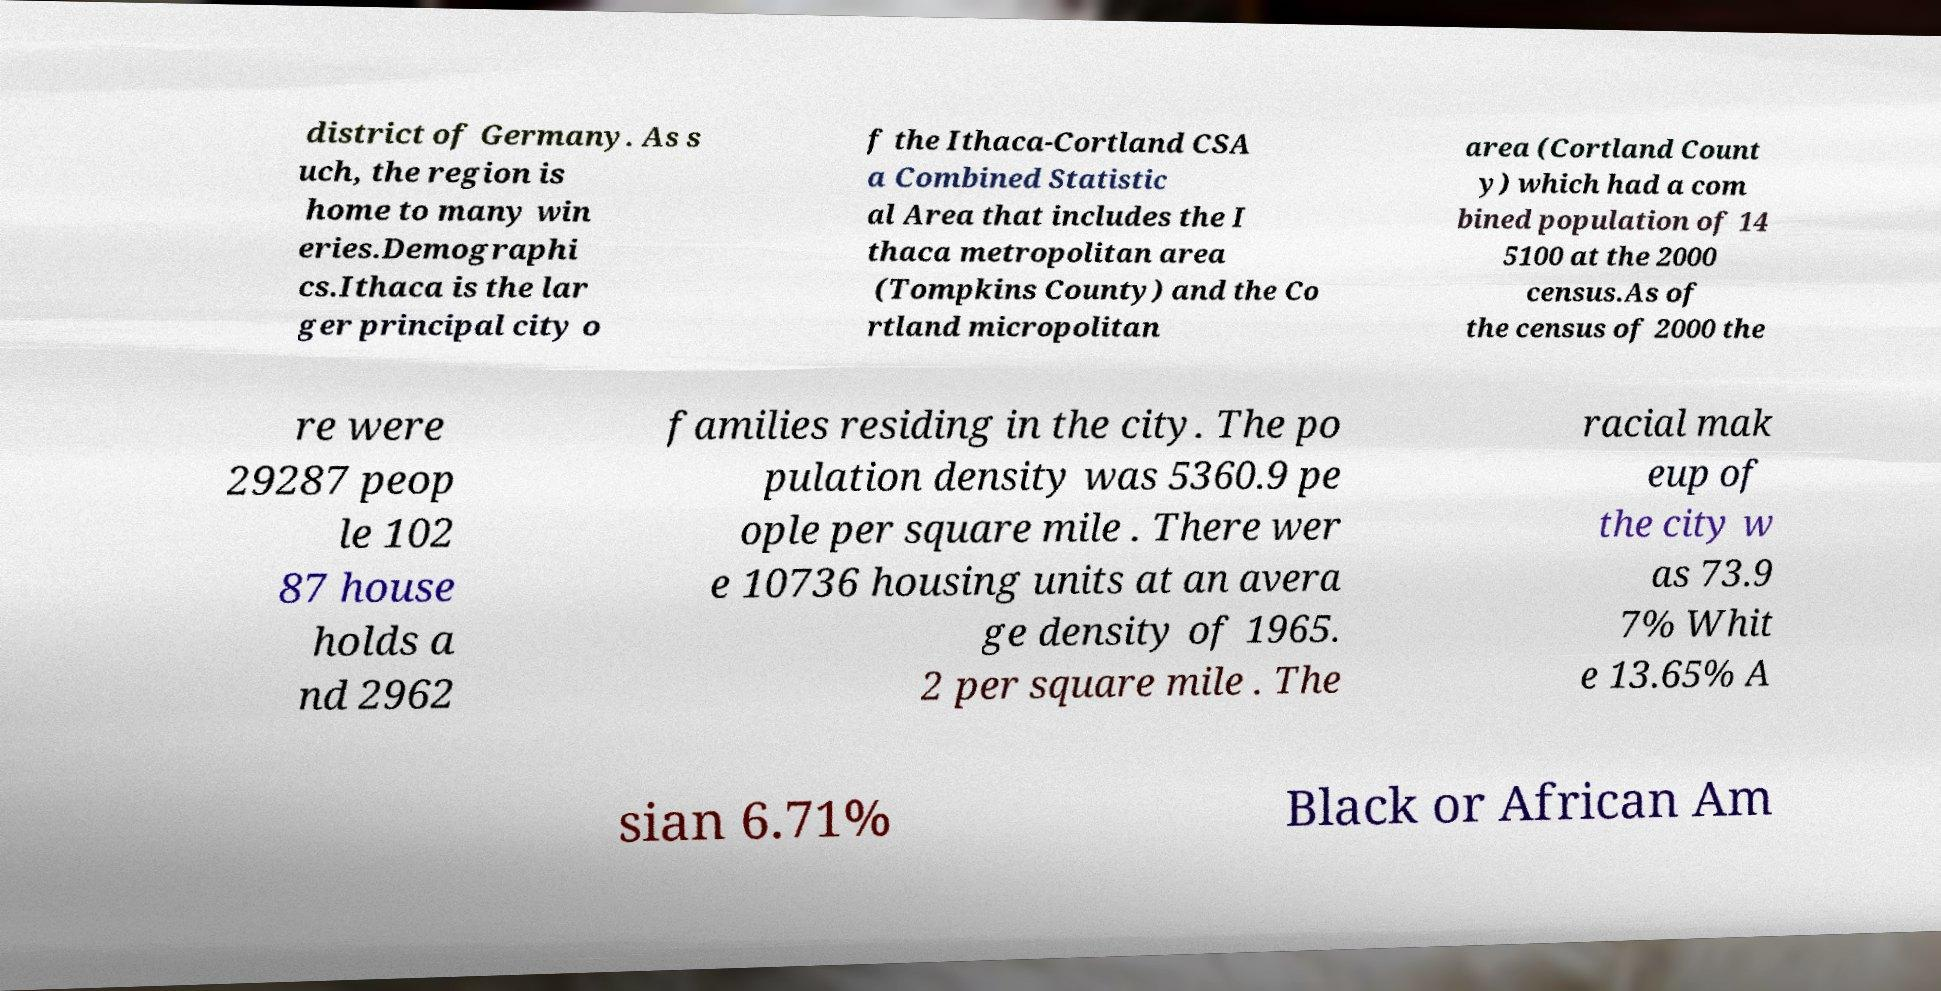There's text embedded in this image that I need extracted. Can you transcribe it verbatim? district of Germany. As s uch, the region is home to many win eries.Demographi cs.Ithaca is the lar ger principal city o f the Ithaca-Cortland CSA a Combined Statistic al Area that includes the I thaca metropolitan area (Tompkins County) and the Co rtland micropolitan area (Cortland Count y) which had a com bined population of 14 5100 at the 2000 census.As of the census of 2000 the re were 29287 peop le 102 87 house holds a nd 2962 families residing in the city. The po pulation density was 5360.9 pe ople per square mile . There wer e 10736 housing units at an avera ge density of 1965. 2 per square mile . The racial mak eup of the city w as 73.9 7% Whit e 13.65% A sian 6.71% Black or African Am 